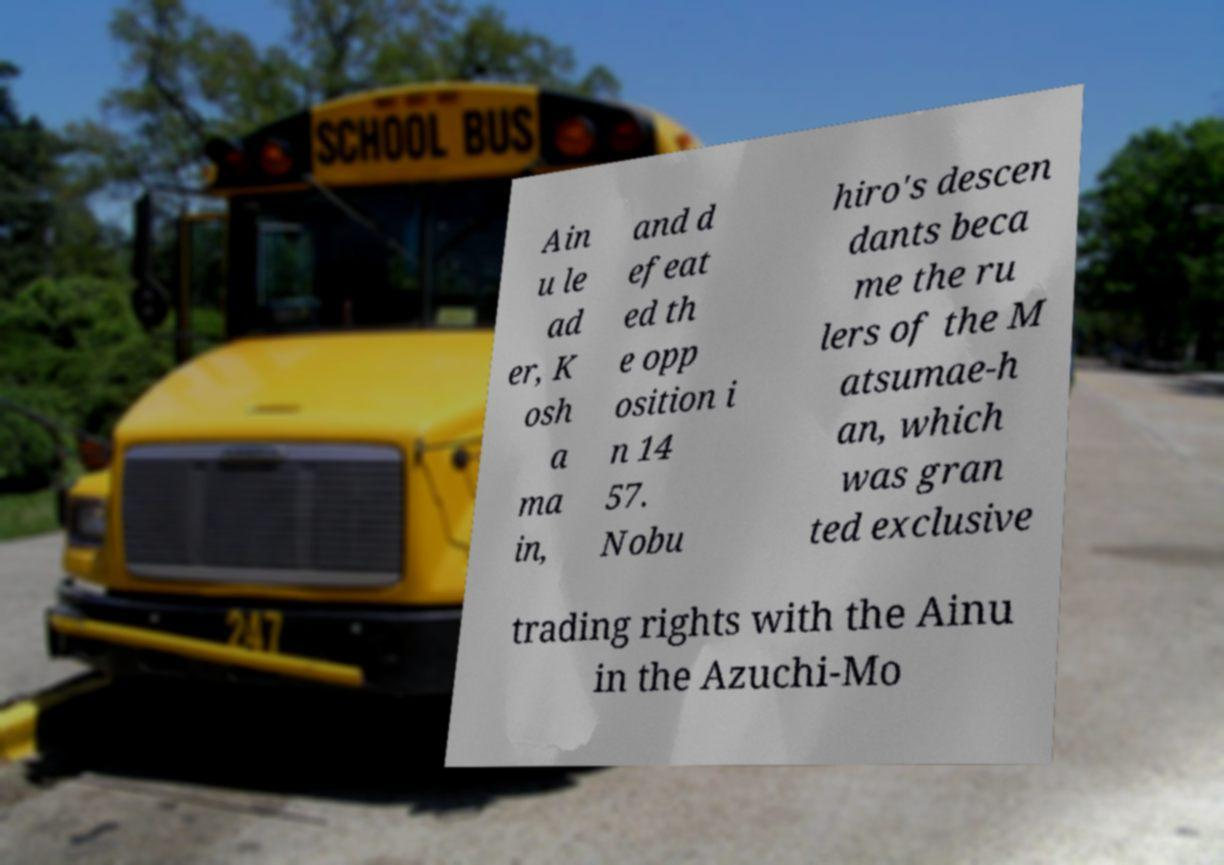What messages or text are displayed in this image? I need them in a readable, typed format. Ain u le ad er, K osh a ma in, and d efeat ed th e opp osition i n 14 57. Nobu hiro's descen dants beca me the ru lers of the M atsumae-h an, which was gran ted exclusive trading rights with the Ainu in the Azuchi-Mo 